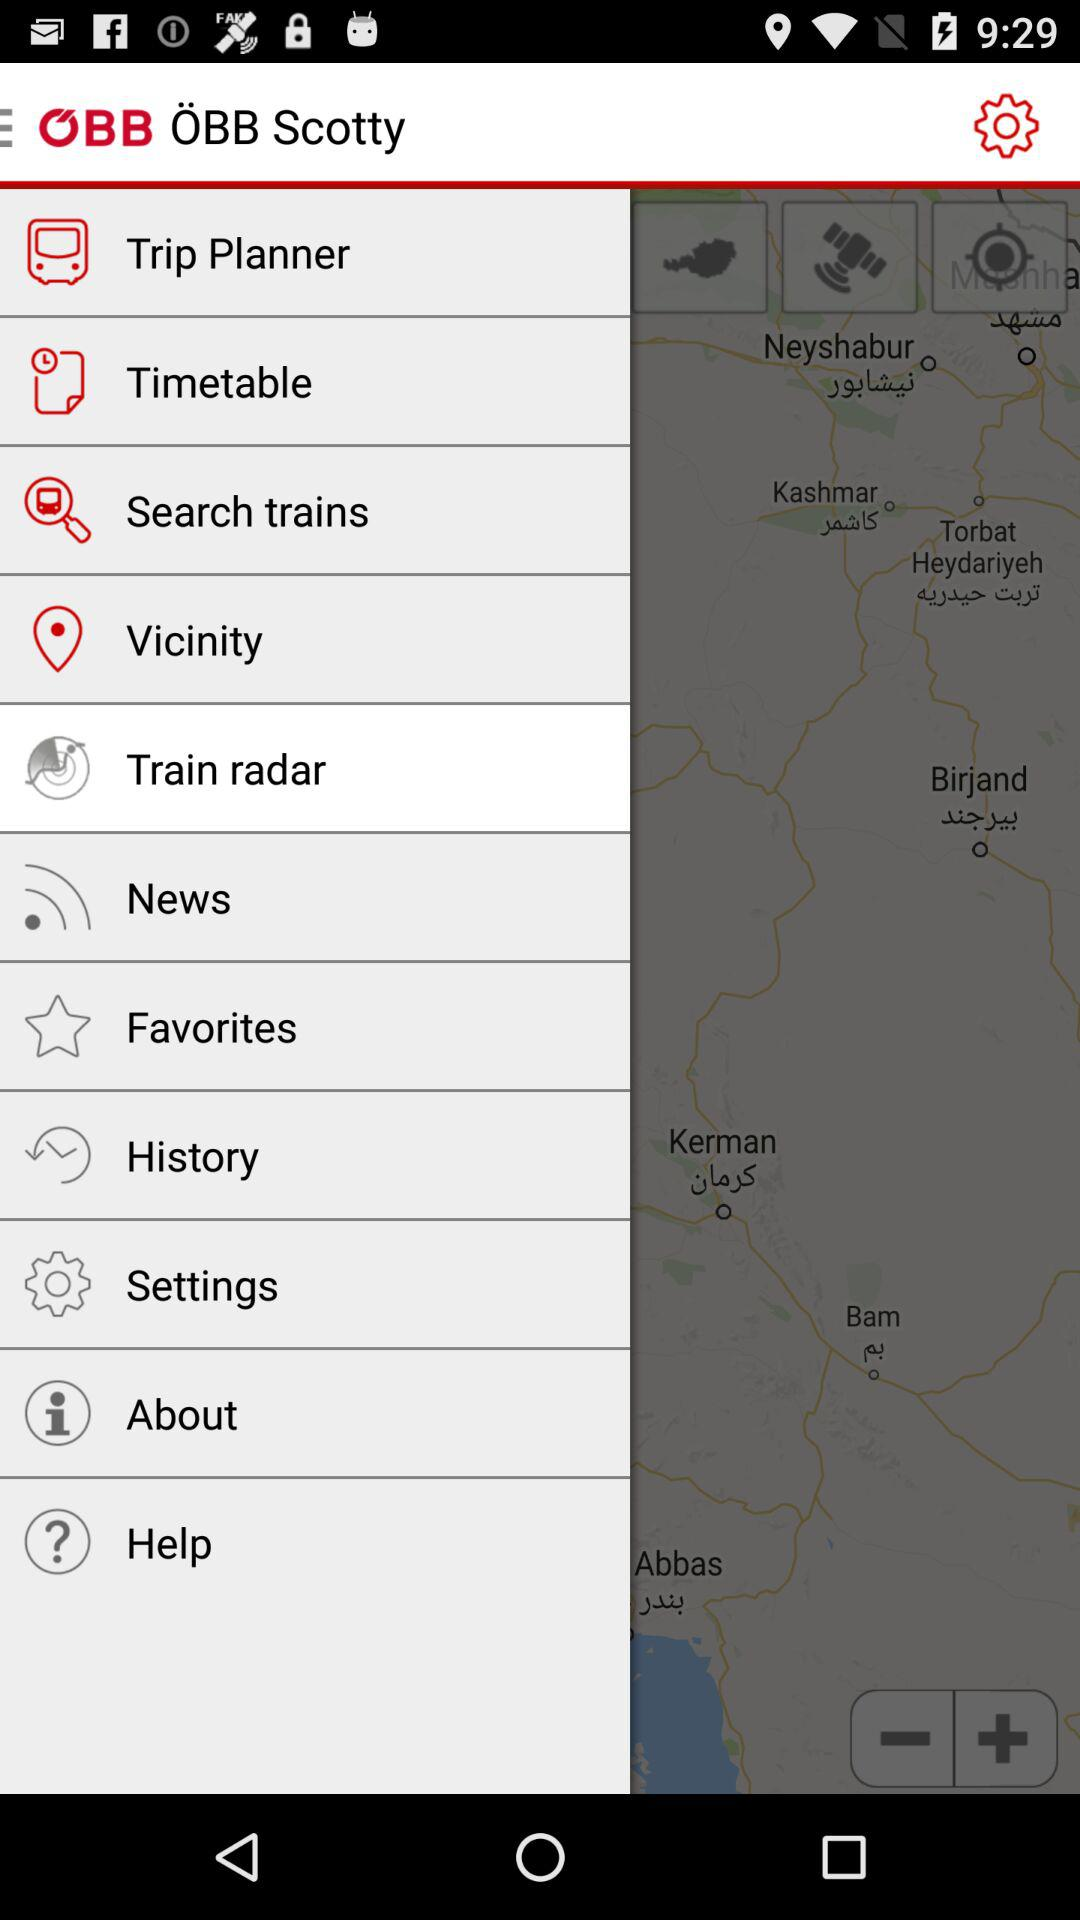What is the name of the application? The name of the application is "ÖBB Scotty". 